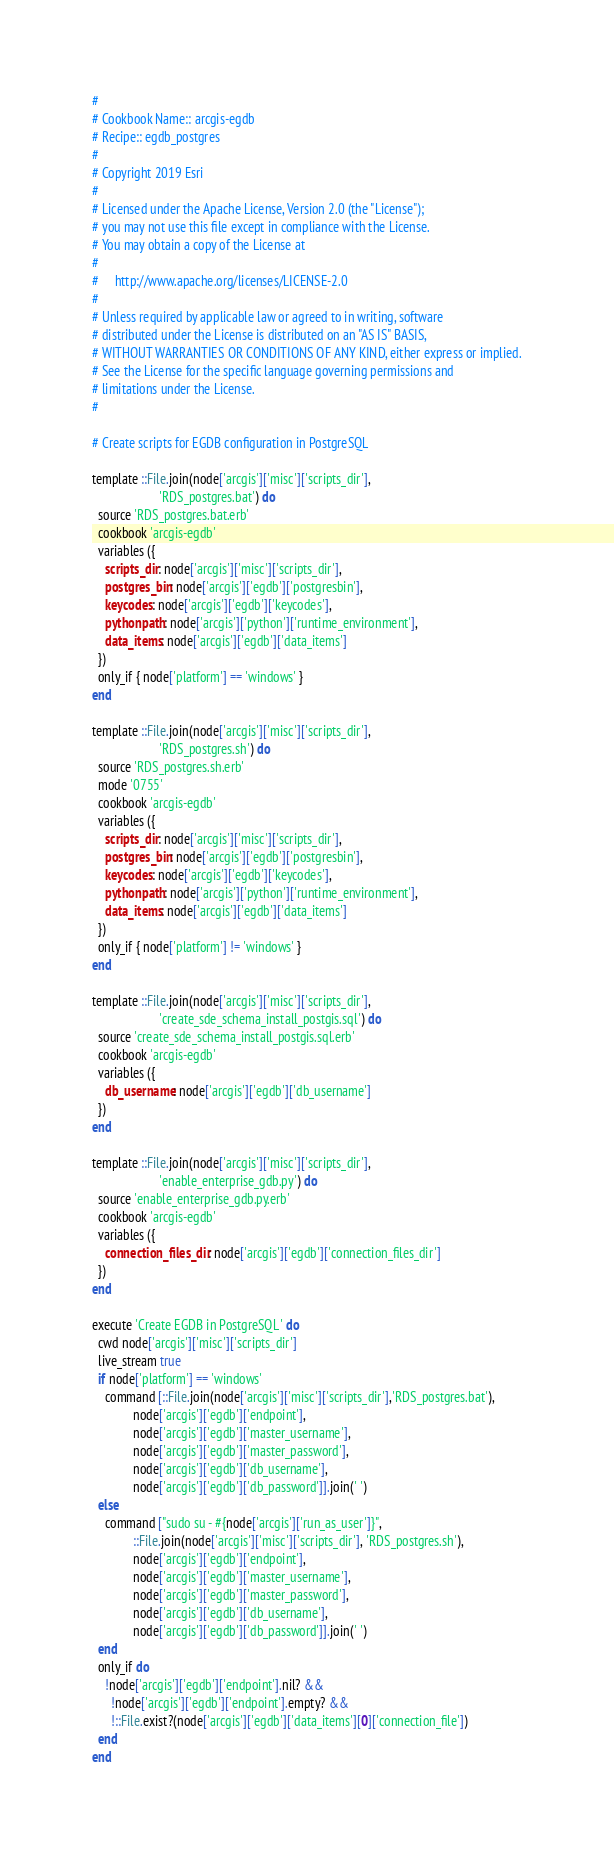<code> <loc_0><loc_0><loc_500><loc_500><_Ruby_>#
# Cookbook Name:: arcgis-egdb
# Recipe:: egdb_postgres
#
# Copyright 2019 Esri
#
# Licensed under the Apache License, Version 2.0 (the "License");
# you may not use this file except in compliance with the License.
# You may obtain a copy of the License at
#
#     http://www.apache.org/licenses/LICENSE-2.0
#
# Unless required by applicable law or agreed to in writing, software
# distributed under the License is distributed on an "AS IS" BASIS,
# WITHOUT WARRANTIES OR CONDITIONS OF ANY KIND, either express or implied.
# See the License for the specific language governing permissions and
# limitations under the License.
#

# Create scripts for EGDB configuration in PostgreSQL

template ::File.join(node['arcgis']['misc']['scripts_dir'],
                     'RDS_postgres.bat') do
  source 'RDS_postgres.bat.erb'
  cookbook 'arcgis-egdb'
  variables ({
    scripts_dir: node['arcgis']['misc']['scripts_dir'],
    postgres_bin: node['arcgis']['egdb']['postgresbin'],
    keycodes: node['arcgis']['egdb']['keycodes'],
    pythonpath: node['arcgis']['python']['runtime_environment'],
    data_items: node['arcgis']['egdb']['data_items']
  })
  only_if { node['platform'] == 'windows' }
end

template ::File.join(node['arcgis']['misc']['scripts_dir'],
                     'RDS_postgres.sh') do
  source 'RDS_postgres.sh.erb'
  mode '0755'
  cookbook 'arcgis-egdb'
  variables ({
    scripts_dir: node['arcgis']['misc']['scripts_dir'],
    postgres_bin: node['arcgis']['egdb']['postgresbin'],
    keycodes: node['arcgis']['egdb']['keycodes'],
    pythonpath: node['arcgis']['python']['runtime_environment'],
    data_items: node['arcgis']['egdb']['data_items']
  })
  only_if { node['platform'] != 'windows' }
end

template ::File.join(node['arcgis']['misc']['scripts_dir'],
                     'create_sde_schema_install_postgis.sql') do
  source 'create_sde_schema_install_postgis.sql.erb'
  cookbook 'arcgis-egdb'
  variables ({
    db_username: node['arcgis']['egdb']['db_username']
  })
end

template ::File.join(node['arcgis']['misc']['scripts_dir'],
                     'enable_enterprise_gdb.py') do
  source 'enable_enterprise_gdb.py.erb'
  cookbook 'arcgis-egdb'
  variables ({
    connection_files_dir: node['arcgis']['egdb']['connection_files_dir']
  })
end

execute 'Create EGDB in PostgreSQL' do
  cwd node['arcgis']['misc']['scripts_dir']
  live_stream true
  if node['platform'] == 'windows'
    command [::File.join(node['arcgis']['misc']['scripts_dir'],'RDS_postgres.bat'),
             node['arcgis']['egdb']['endpoint'],
             node['arcgis']['egdb']['master_username'],
             node['arcgis']['egdb']['master_password'],
             node['arcgis']['egdb']['db_username'],
             node['arcgis']['egdb']['db_password']].join(' ')
  else
    command ["sudo su - #{node['arcgis']['run_as_user']}",
             ::File.join(node['arcgis']['misc']['scripts_dir'], 'RDS_postgres.sh'),
             node['arcgis']['egdb']['endpoint'],
             node['arcgis']['egdb']['master_username'],
             node['arcgis']['egdb']['master_password'],
             node['arcgis']['egdb']['db_username'],
             node['arcgis']['egdb']['db_password']].join(' ')
  end
  only_if do
    !node['arcgis']['egdb']['endpoint'].nil? &&
      !node['arcgis']['egdb']['endpoint'].empty? &&
      !::File.exist?(node['arcgis']['egdb']['data_items'][0]['connection_file'])
  end
end
</code> 